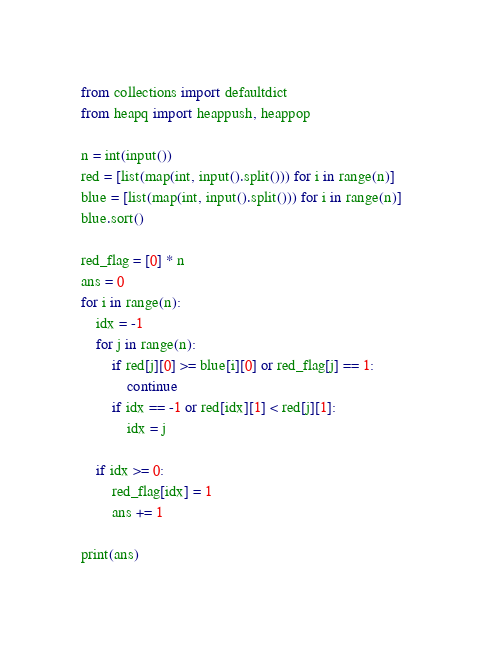<code> <loc_0><loc_0><loc_500><loc_500><_Python_>from collections import defaultdict
from heapq import heappush, heappop

n = int(input())
red = [list(map(int, input().split())) for i in range(n)]
blue = [list(map(int, input().split())) for i in range(n)]
blue.sort()

red_flag = [0] * n
ans = 0
for i in range(n):
    idx = -1
    for j in range(n):
        if red[j][0] >= blue[i][0] or red_flag[j] == 1:
            continue
        if idx == -1 or red[idx][1] < red[j][1]:
            idx = j

    if idx >= 0:
        red_flag[idx] = 1
        ans += 1

print(ans)
</code> 